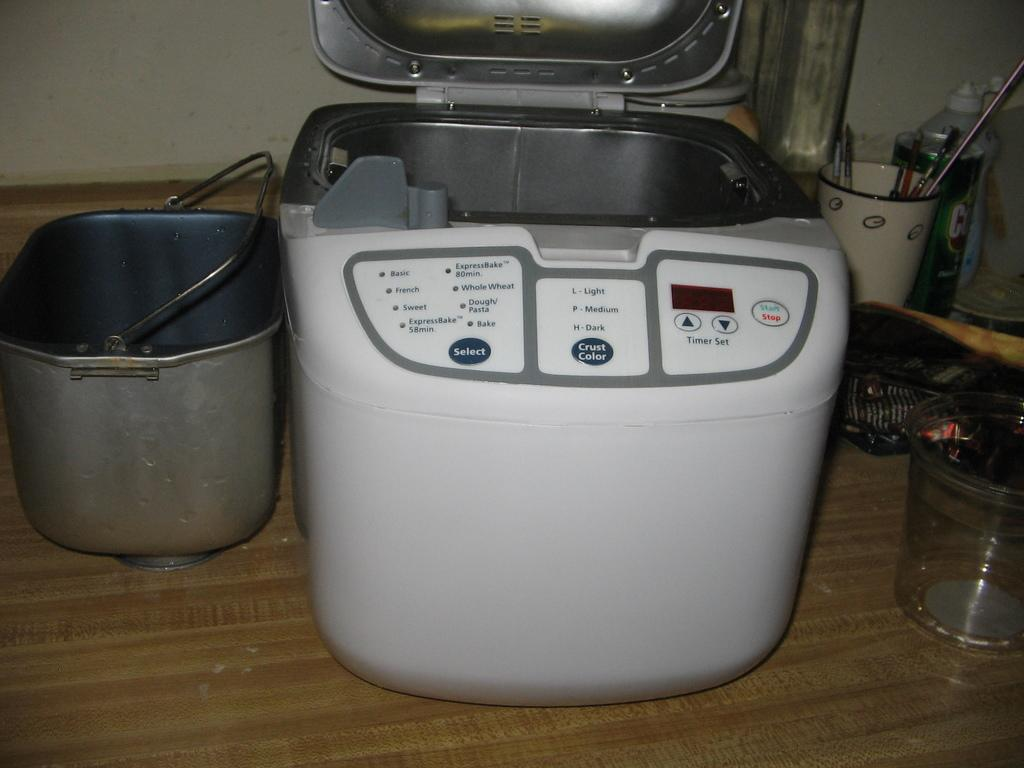<image>
Provide a brief description of the given image. a bread maker with options for whole wheat, french, and sweet bread baking times 